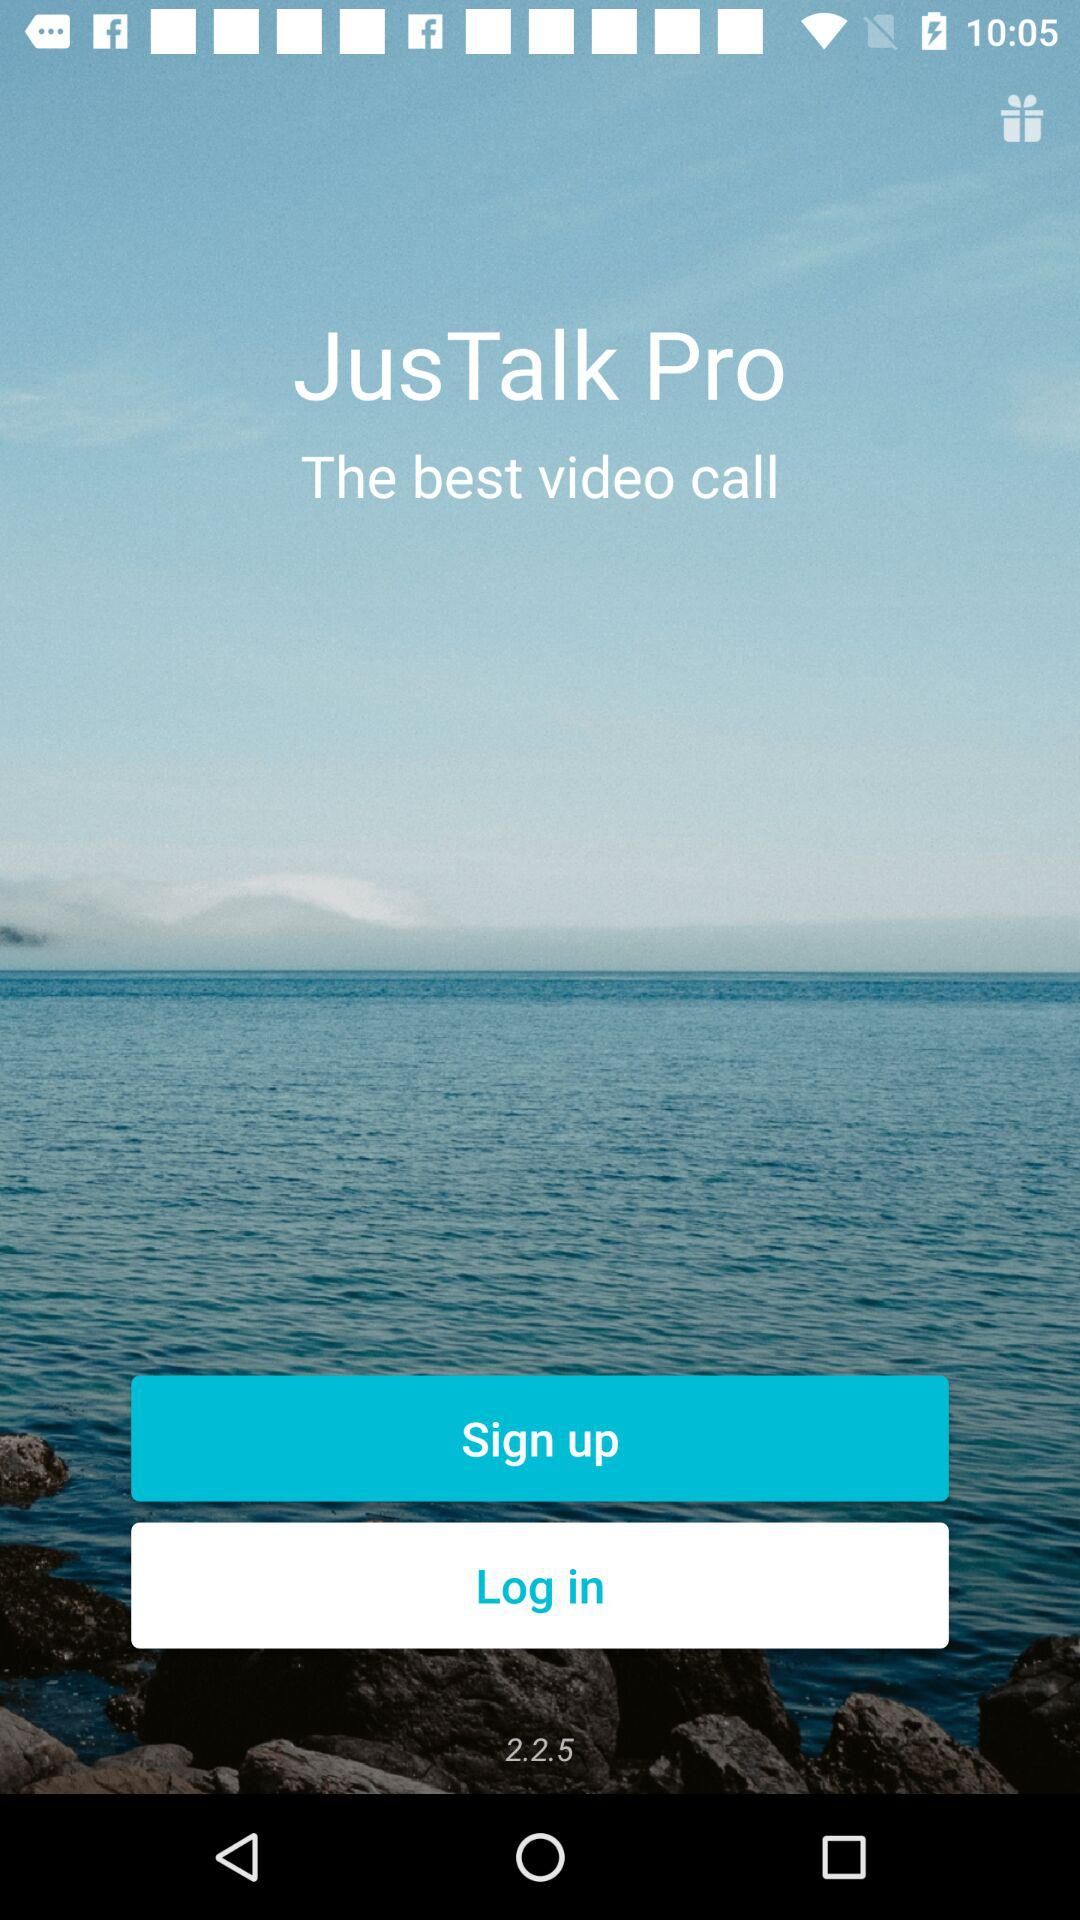Who is signing up?
When the provided information is insufficient, respond with <no answer>. <no answer> 